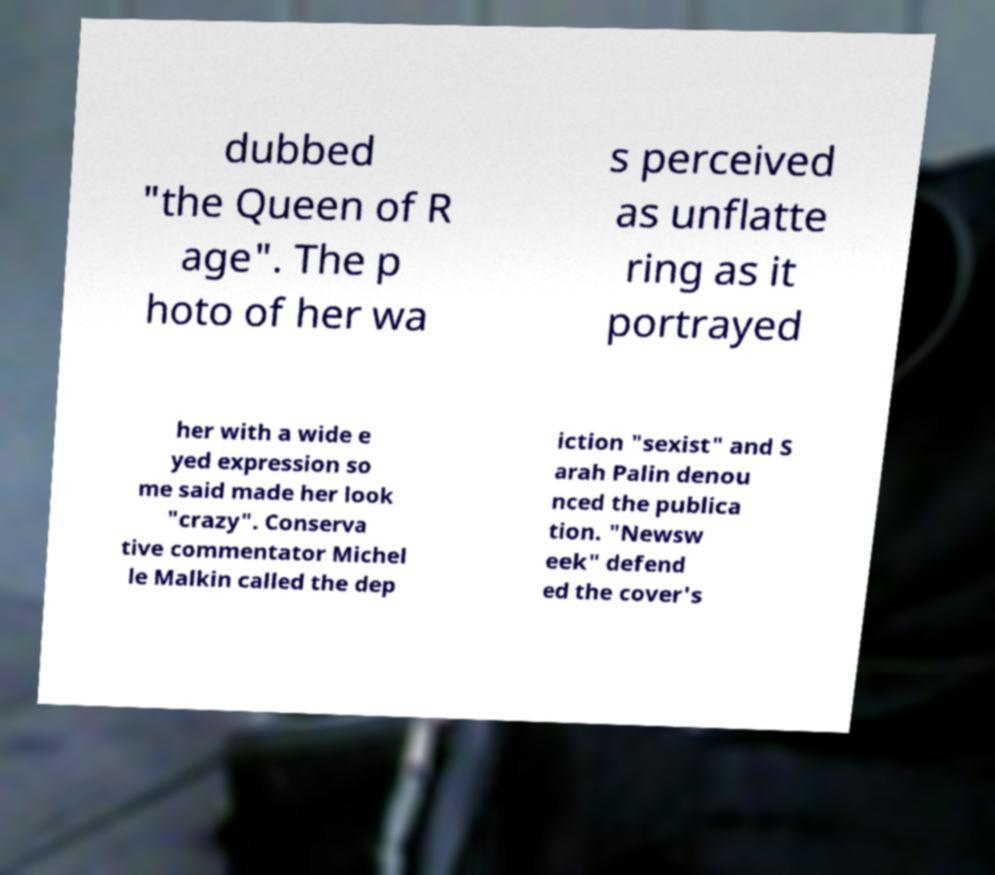Please identify and transcribe the text found in this image. dubbed "the Queen of R age". The p hoto of her wa s perceived as unflatte ring as it portrayed her with a wide e yed expression so me said made her look "crazy". Conserva tive commentator Michel le Malkin called the dep iction "sexist" and S arah Palin denou nced the publica tion. "Newsw eek" defend ed the cover's 